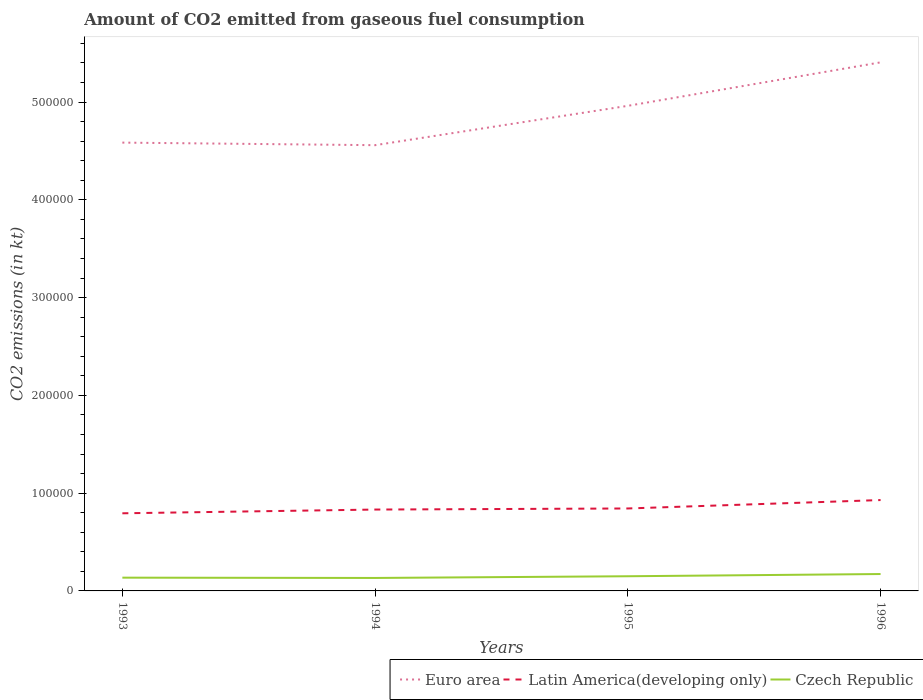Does the line corresponding to Czech Republic intersect with the line corresponding to Latin America(developing only)?
Provide a short and direct response. No. Across all years, what is the maximum amount of CO2 emitted in Euro area?
Provide a short and direct response. 4.56e+05. In which year was the amount of CO2 emitted in Latin America(developing only) maximum?
Keep it short and to the point. 1993. What is the total amount of CO2 emitted in Czech Republic in the graph?
Offer a very short reply. -2262.54. What is the difference between the highest and the second highest amount of CO2 emitted in Latin America(developing only)?
Offer a very short reply. 1.35e+04. What is the difference between two consecutive major ticks on the Y-axis?
Your answer should be compact. 1.00e+05. Does the graph contain any zero values?
Provide a succinct answer. No. Where does the legend appear in the graph?
Offer a very short reply. Bottom right. How are the legend labels stacked?
Offer a very short reply. Horizontal. What is the title of the graph?
Keep it short and to the point. Amount of CO2 emitted from gaseous fuel consumption. What is the label or title of the X-axis?
Offer a very short reply. Years. What is the label or title of the Y-axis?
Provide a short and direct response. CO2 emissions (in kt). What is the CO2 emissions (in kt) in Euro area in 1993?
Ensure brevity in your answer.  4.59e+05. What is the CO2 emissions (in kt) of Latin America(developing only) in 1993?
Make the answer very short. 7.94e+04. What is the CO2 emissions (in kt) in Czech Republic in 1993?
Your response must be concise. 1.36e+04. What is the CO2 emissions (in kt) of Euro area in 1994?
Provide a short and direct response. 4.56e+05. What is the CO2 emissions (in kt) in Latin America(developing only) in 1994?
Your answer should be very brief. 8.32e+04. What is the CO2 emissions (in kt) in Czech Republic in 1994?
Keep it short and to the point. 1.33e+04. What is the CO2 emissions (in kt) of Euro area in 1995?
Offer a terse response. 4.96e+05. What is the CO2 emissions (in kt) in Latin America(developing only) in 1995?
Offer a terse response. 8.43e+04. What is the CO2 emissions (in kt) of Czech Republic in 1995?
Ensure brevity in your answer.  1.50e+04. What is the CO2 emissions (in kt) of Euro area in 1996?
Provide a short and direct response. 5.41e+05. What is the CO2 emissions (in kt) in Latin America(developing only) in 1996?
Provide a short and direct response. 9.29e+04. What is the CO2 emissions (in kt) in Czech Republic in 1996?
Offer a very short reply. 1.73e+04. Across all years, what is the maximum CO2 emissions (in kt) of Euro area?
Your answer should be compact. 5.41e+05. Across all years, what is the maximum CO2 emissions (in kt) of Latin America(developing only)?
Make the answer very short. 9.29e+04. Across all years, what is the maximum CO2 emissions (in kt) in Czech Republic?
Provide a succinct answer. 1.73e+04. Across all years, what is the minimum CO2 emissions (in kt) of Euro area?
Offer a very short reply. 4.56e+05. Across all years, what is the minimum CO2 emissions (in kt) of Latin America(developing only)?
Offer a very short reply. 7.94e+04. Across all years, what is the minimum CO2 emissions (in kt) in Czech Republic?
Ensure brevity in your answer.  1.33e+04. What is the total CO2 emissions (in kt) in Euro area in the graph?
Provide a short and direct response. 1.95e+06. What is the total CO2 emissions (in kt) of Latin America(developing only) in the graph?
Give a very brief answer. 3.40e+05. What is the total CO2 emissions (in kt) of Czech Republic in the graph?
Make the answer very short. 5.91e+04. What is the difference between the CO2 emissions (in kt) of Euro area in 1993 and that in 1994?
Your answer should be compact. 2624.82. What is the difference between the CO2 emissions (in kt) of Latin America(developing only) in 1993 and that in 1994?
Your answer should be very brief. -3825.4. What is the difference between the CO2 emissions (in kt) in Czech Republic in 1993 and that in 1994?
Your response must be concise. 315.36. What is the difference between the CO2 emissions (in kt) of Euro area in 1993 and that in 1995?
Your response must be concise. -3.76e+04. What is the difference between the CO2 emissions (in kt) of Latin America(developing only) in 1993 and that in 1995?
Offer a terse response. -4936.26. What is the difference between the CO2 emissions (in kt) in Czech Republic in 1993 and that in 1995?
Provide a succinct answer. -1430.13. What is the difference between the CO2 emissions (in kt) of Euro area in 1993 and that in 1996?
Offer a very short reply. -8.21e+04. What is the difference between the CO2 emissions (in kt) in Latin America(developing only) in 1993 and that in 1996?
Offer a terse response. -1.35e+04. What is the difference between the CO2 emissions (in kt) in Czech Republic in 1993 and that in 1996?
Offer a very short reply. -3692.67. What is the difference between the CO2 emissions (in kt) in Euro area in 1994 and that in 1995?
Provide a short and direct response. -4.03e+04. What is the difference between the CO2 emissions (in kt) in Latin America(developing only) in 1994 and that in 1995?
Give a very brief answer. -1110.85. What is the difference between the CO2 emissions (in kt) of Czech Republic in 1994 and that in 1995?
Give a very brief answer. -1745.49. What is the difference between the CO2 emissions (in kt) in Euro area in 1994 and that in 1996?
Your response must be concise. -8.47e+04. What is the difference between the CO2 emissions (in kt) in Latin America(developing only) in 1994 and that in 1996?
Keep it short and to the point. -9716.05. What is the difference between the CO2 emissions (in kt) in Czech Republic in 1994 and that in 1996?
Offer a terse response. -4008.03. What is the difference between the CO2 emissions (in kt) in Euro area in 1995 and that in 1996?
Your answer should be compact. -4.45e+04. What is the difference between the CO2 emissions (in kt) in Latin America(developing only) in 1995 and that in 1996?
Provide a short and direct response. -8605.2. What is the difference between the CO2 emissions (in kt) in Czech Republic in 1995 and that in 1996?
Provide a succinct answer. -2262.54. What is the difference between the CO2 emissions (in kt) in Euro area in 1993 and the CO2 emissions (in kt) in Latin America(developing only) in 1994?
Provide a succinct answer. 3.75e+05. What is the difference between the CO2 emissions (in kt) of Euro area in 1993 and the CO2 emissions (in kt) of Czech Republic in 1994?
Your answer should be compact. 4.45e+05. What is the difference between the CO2 emissions (in kt) of Latin America(developing only) in 1993 and the CO2 emissions (in kt) of Czech Republic in 1994?
Give a very brief answer. 6.61e+04. What is the difference between the CO2 emissions (in kt) in Euro area in 1993 and the CO2 emissions (in kt) in Latin America(developing only) in 1995?
Provide a short and direct response. 3.74e+05. What is the difference between the CO2 emissions (in kt) in Euro area in 1993 and the CO2 emissions (in kt) in Czech Republic in 1995?
Make the answer very short. 4.44e+05. What is the difference between the CO2 emissions (in kt) of Latin America(developing only) in 1993 and the CO2 emissions (in kt) of Czech Republic in 1995?
Give a very brief answer. 6.44e+04. What is the difference between the CO2 emissions (in kt) in Euro area in 1993 and the CO2 emissions (in kt) in Latin America(developing only) in 1996?
Provide a succinct answer. 3.66e+05. What is the difference between the CO2 emissions (in kt) in Euro area in 1993 and the CO2 emissions (in kt) in Czech Republic in 1996?
Give a very brief answer. 4.41e+05. What is the difference between the CO2 emissions (in kt) of Latin America(developing only) in 1993 and the CO2 emissions (in kt) of Czech Republic in 1996?
Make the answer very short. 6.21e+04. What is the difference between the CO2 emissions (in kt) in Euro area in 1994 and the CO2 emissions (in kt) in Latin America(developing only) in 1995?
Offer a very short reply. 3.72e+05. What is the difference between the CO2 emissions (in kt) in Euro area in 1994 and the CO2 emissions (in kt) in Czech Republic in 1995?
Provide a short and direct response. 4.41e+05. What is the difference between the CO2 emissions (in kt) in Latin America(developing only) in 1994 and the CO2 emissions (in kt) in Czech Republic in 1995?
Give a very brief answer. 6.82e+04. What is the difference between the CO2 emissions (in kt) of Euro area in 1994 and the CO2 emissions (in kt) of Latin America(developing only) in 1996?
Offer a terse response. 3.63e+05. What is the difference between the CO2 emissions (in kt) in Euro area in 1994 and the CO2 emissions (in kt) in Czech Republic in 1996?
Give a very brief answer. 4.39e+05. What is the difference between the CO2 emissions (in kt) of Latin America(developing only) in 1994 and the CO2 emissions (in kt) of Czech Republic in 1996?
Provide a short and direct response. 6.60e+04. What is the difference between the CO2 emissions (in kt) of Euro area in 1995 and the CO2 emissions (in kt) of Latin America(developing only) in 1996?
Keep it short and to the point. 4.03e+05. What is the difference between the CO2 emissions (in kt) of Euro area in 1995 and the CO2 emissions (in kt) of Czech Republic in 1996?
Offer a very short reply. 4.79e+05. What is the difference between the CO2 emissions (in kt) in Latin America(developing only) in 1995 and the CO2 emissions (in kt) in Czech Republic in 1996?
Offer a terse response. 6.71e+04. What is the average CO2 emissions (in kt) in Euro area per year?
Offer a very short reply. 4.88e+05. What is the average CO2 emissions (in kt) in Latin America(developing only) per year?
Offer a very short reply. 8.50e+04. What is the average CO2 emissions (in kt) in Czech Republic per year?
Ensure brevity in your answer.  1.48e+04. In the year 1993, what is the difference between the CO2 emissions (in kt) of Euro area and CO2 emissions (in kt) of Latin America(developing only)?
Provide a short and direct response. 3.79e+05. In the year 1993, what is the difference between the CO2 emissions (in kt) in Euro area and CO2 emissions (in kt) in Czech Republic?
Give a very brief answer. 4.45e+05. In the year 1993, what is the difference between the CO2 emissions (in kt) of Latin America(developing only) and CO2 emissions (in kt) of Czech Republic?
Your answer should be very brief. 6.58e+04. In the year 1994, what is the difference between the CO2 emissions (in kt) in Euro area and CO2 emissions (in kt) in Latin America(developing only)?
Make the answer very short. 3.73e+05. In the year 1994, what is the difference between the CO2 emissions (in kt) of Euro area and CO2 emissions (in kt) of Czech Republic?
Make the answer very short. 4.43e+05. In the year 1994, what is the difference between the CO2 emissions (in kt) of Latin America(developing only) and CO2 emissions (in kt) of Czech Republic?
Offer a very short reply. 7.00e+04. In the year 1995, what is the difference between the CO2 emissions (in kt) in Euro area and CO2 emissions (in kt) in Latin America(developing only)?
Make the answer very short. 4.12e+05. In the year 1995, what is the difference between the CO2 emissions (in kt) in Euro area and CO2 emissions (in kt) in Czech Republic?
Your answer should be very brief. 4.81e+05. In the year 1995, what is the difference between the CO2 emissions (in kt) in Latin America(developing only) and CO2 emissions (in kt) in Czech Republic?
Offer a very short reply. 6.93e+04. In the year 1996, what is the difference between the CO2 emissions (in kt) of Euro area and CO2 emissions (in kt) of Latin America(developing only)?
Offer a very short reply. 4.48e+05. In the year 1996, what is the difference between the CO2 emissions (in kt) in Euro area and CO2 emissions (in kt) in Czech Republic?
Offer a very short reply. 5.23e+05. In the year 1996, what is the difference between the CO2 emissions (in kt) in Latin America(developing only) and CO2 emissions (in kt) in Czech Republic?
Your answer should be compact. 7.57e+04. What is the ratio of the CO2 emissions (in kt) in Euro area in 1993 to that in 1994?
Your answer should be compact. 1.01. What is the ratio of the CO2 emissions (in kt) of Latin America(developing only) in 1993 to that in 1994?
Ensure brevity in your answer.  0.95. What is the ratio of the CO2 emissions (in kt) in Czech Republic in 1993 to that in 1994?
Ensure brevity in your answer.  1.02. What is the ratio of the CO2 emissions (in kt) in Euro area in 1993 to that in 1995?
Your answer should be compact. 0.92. What is the ratio of the CO2 emissions (in kt) in Latin America(developing only) in 1993 to that in 1995?
Keep it short and to the point. 0.94. What is the ratio of the CO2 emissions (in kt) of Czech Republic in 1993 to that in 1995?
Provide a short and direct response. 0.9. What is the ratio of the CO2 emissions (in kt) in Euro area in 1993 to that in 1996?
Provide a succinct answer. 0.85. What is the ratio of the CO2 emissions (in kt) of Latin America(developing only) in 1993 to that in 1996?
Offer a terse response. 0.85. What is the ratio of the CO2 emissions (in kt) of Czech Republic in 1993 to that in 1996?
Your response must be concise. 0.79. What is the ratio of the CO2 emissions (in kt) in Euro area in 1994 to that in 1995?
Offer a terse response. 0.92. What is the ratio of the CO2 emissions (in kt) in Czech Republic in 1994 to that in 1995?
Offer a very short reply. 0.88. What is the ratio of the CO2 emissions (in kt) of Euro area in 1994 to that in 1996?
Offer a very short reply. 0.84. What is the ratio of the CO2 emissions (in kt) of Latin America(developing only) in 1994 to that in 1996?
Provide a succinct answer. 0.9. What is the ratio of the CO2 emissions (in kt) in Czech Republic in 1994 to that in 1996?
Keep it short and to the point. 0.77. What is the ratio of the CO2 emissions (in kt) in Euro area in 1995 to that in 1996?
Provide a succinct answer. 0.92. What is the ratio of the CO2 emissions (in kt) in Latin America(developing only) in 1995 to that in 1996?
Your answer should be compact. 0.91. What is the ratio of the CO2 emissions (in kt) of Czech Republic in 1995 to that in 1996?
Your response must be concise. 0.87. What is the difference between the highest and the second highest CO2 emissions (in kt) in Euro area?
Offer a terse response. 4.45e+04. What is the difference between the highest and the second highest CO2 emissions (in kt) of Latin America(developing only)?
Keep it short and to the point. 8605.2. What is the difference between the highest and the second highest CO2 emissions (in kt) in Czech Republic?
Your answer should be compact. 2262.54. What is the difference between the highest and the lowest CO2 emissions (in kt) in Euro area?
Make the answer very short. 8.47e+04. What is the difference between the highest and the lowest CO2 emissions (in kt) of Latin America(developing only)?
Keep it short and to the point. 1.35e+04. What is the difference between the highest and the lowest CO2 emissions (in kt) in Czech Republic?
Your answer should be very brief. 4008.03. 